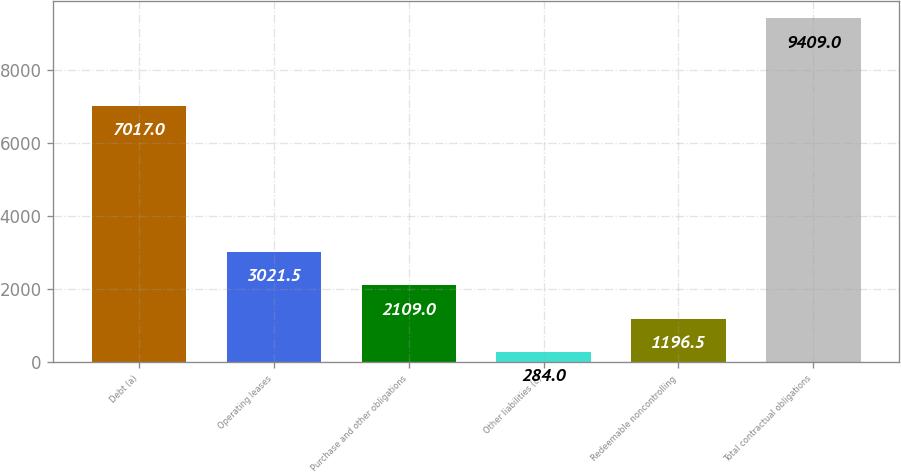<chart> <loc_0><loc_0><loc_500><loc_500><bar_chart><fcel>Debt (a)<fcel>Operating leases<fcel>Purchase and other obligations<fcel>Other liabilities (c)<fcel>Redeemable noncontrolling<fcel>Total contractual obligations<nl><fcel>7017<fcel>3021.5<fcel>2109<fcel>284<fcel>1196.5<fcel>9409<nl></chart> 